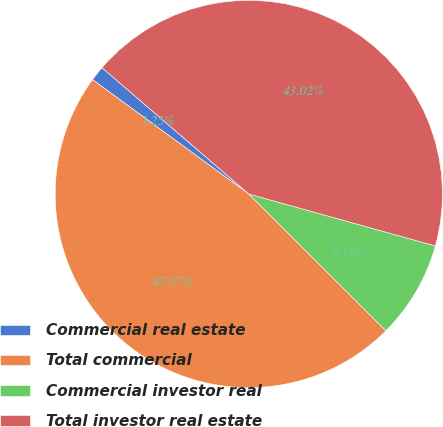Convert chart to OTSL. <chart><loc_0><loc_0><loc_500><loc_500><pie_chart><fcel>Commercial real estate<fcel>Total commercial<fcel>Commercial investor real<fcel>Total investor real estate<nl><fcel>1.25%<fcel>47.57%<fcel>8.16%<fcel>43.02%<nl></chart> 